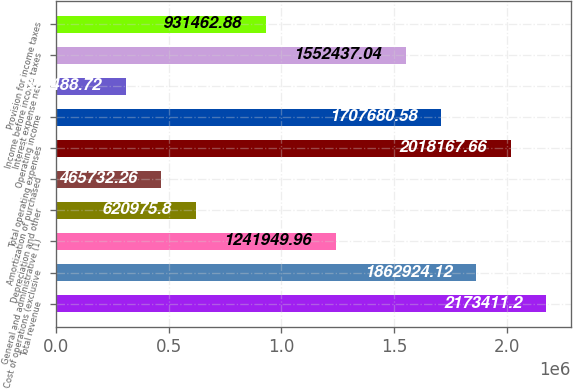<chart> <loc_0><loc_0><loc_500><loc_500><bar_chart><fcel>Total revenue<fcel>Cost of operations (exclusive<fcel>General and administrative (1)<fcel>Depreciation and other<fcel>Amortization of purchased<fcel>Total operating expenses<fcel>Operating income<fcel>Interest expense net<fcel>Income before income taxes<fcel>Provision for income taxes<nl><fcel>2.17341e+06<fcel>1.86292e+06<fcel>1.24195e+06<fcel>620976<fcel>465732<fcel>2.01817e+06<fcel>1.70768e+06<fcel>310489<fcel>1.55244e+06<fcel>931463<nl></chart> 